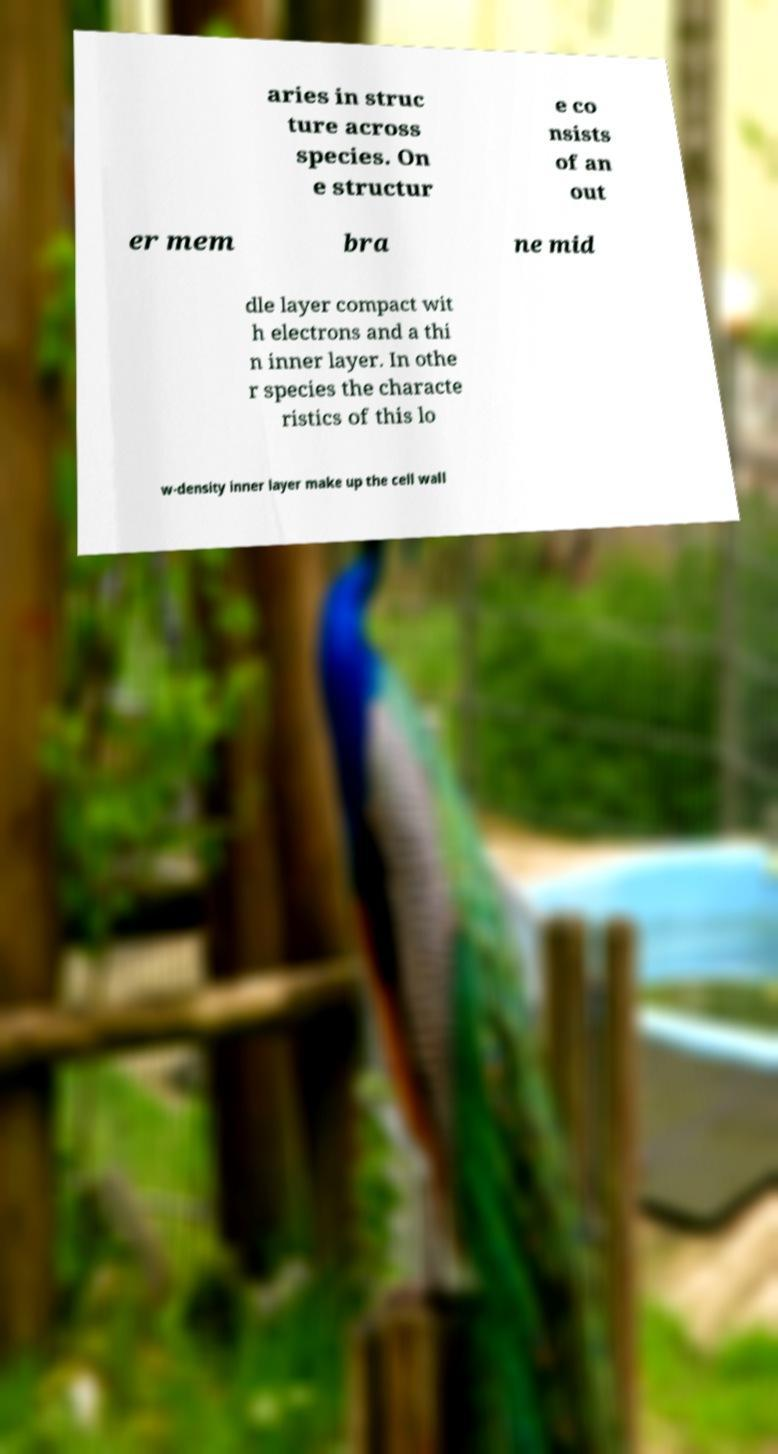Please read and relay the text visible in this image. What does it say? aries in struc ture across species. On e structur e co nsists of an out er mem bra ne mid dle layer compact wit h electrons and a thi n inner layer. In othe r species the characte ristics of this lo w-density inner layer make up the cell wall 